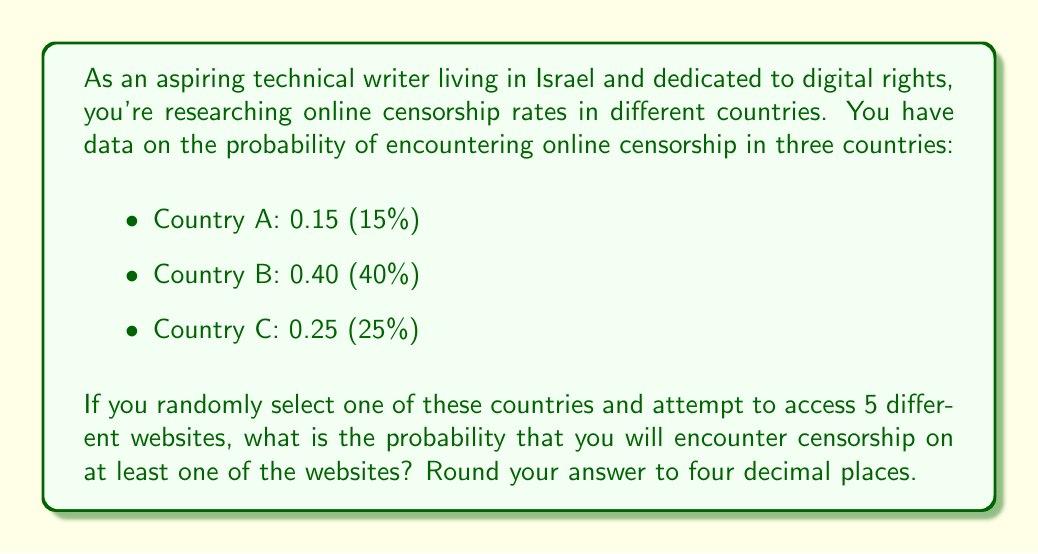Help me with this question. To solve this problem, we'll use the following approach:

1) First, we need to calculate the probability of not encountering censorship on any of the 5 websites for each country.
2) Then, we'll calculate the average of these probabilities across the three countries.
3) Finally, we'll subtract this probability from 1 to get the probability of encountering censorship on at least one website.

Step 1: Probability of not encountering censorship on any of the 5 websites

For Country A:
$P(\text{no censorship in A}) = (1 - 0.15)^5 = 0.85^5 \approx 0.4437$

For Country B:
$P(\text{no censorship in B}) = (1 - 0.40)^5 = 0.60^5 \approx 0.0778$

For Country C:
$P(\text{no censorship in C}) = (1 - 0.25)^5 = 0.75^5 \approx 0.2373$

Step 2: Average probability of not encountering censorship

$P(\text{no censorship}) = \frac{0.4437 + 0.0778 + 0.2373}{3} \approx 0.2529$

Step 3: Probability of encountering censorship on at least one website

$P(\text{censorship on at least one}) = 1 - P(\text{no censorship}) = 1 - 0.2529 \approx 0.7471$

Rounding to four decimal places: 0.7471
Answer: 0.7471 